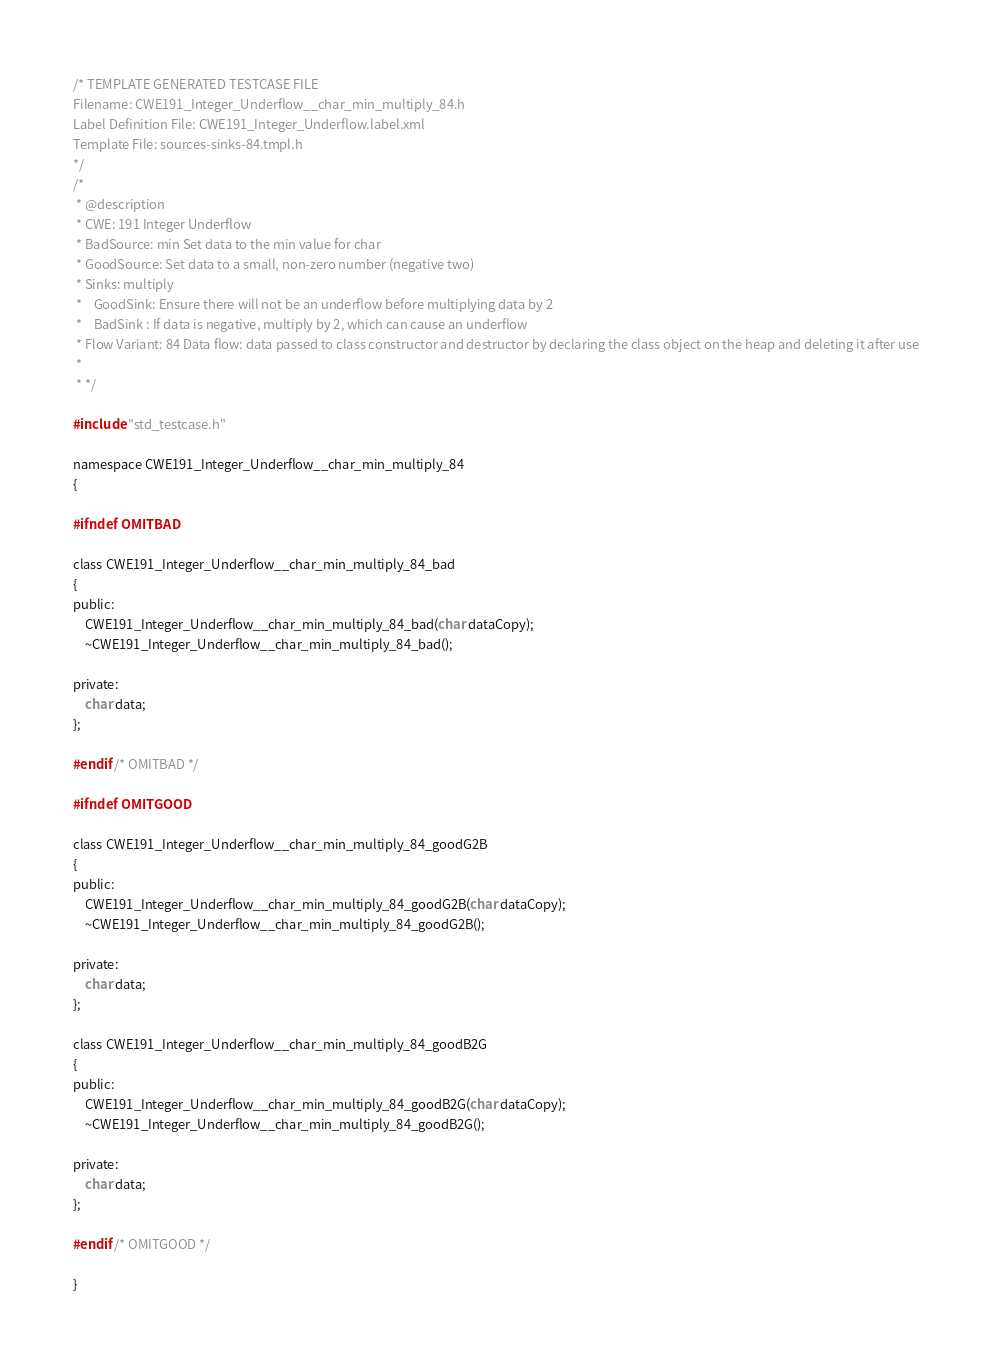<code> <loc_0><loc_0><loc_500><loc_500><_C_>/* TEMPLATE GENERATED TESTCASE FILE
Filename: CWE191_Integer_Underflow__char_min_multiply_84.h
Label Definition File: CWE191_Integer_Underflow.label.xml
Template File: sources-sinks-84.tmpl.h
*/
/*
 * @description
 * CWE: 191 Integer Underflow
 * BadSource: min Set data to the min value for char
 * GoodSource: Set data to a small, non-zero number (negative two)
 * Sinks: multiply
 *    GoodSink: Ensure there will not be an underflow before multiplying data by 2
 *    BadSink : If data is negative, multiply by 2, which can cause an underflow
 * Flow Variant: 84 Data flow: data passed to class constructor and destructor by declaring the class object on the heap and deleting it after use
 *
 * */

#include "std_testcase.h"

namespace CWE191_Integer_Underflow__char_min_multiply_84
{

#ifndef OMITBAD

class CWE191_Integer_Underflow__char_min_multiply_84_bad
{
public:
    CWE191_Integer_Underflow__char_min_multiply_84_bad(char dataCopy);
    ~CWE191_Integer_Underflow__char_min_multiply_84_bad();

private:
    char data;
};

#endif /* OMITBAD */

#ifndef OMITGOOD

class CWE191_Integer_Underflow__char_min_multiply_84_goodG2B
{
public:
    CWE191_Integer_Underflow__char_min_multiply_84_goodG2B(char dataCopy);
    ~CWE191_Integer_Underflow__char_min_multiply_84_goodG2B();

private:
    char data;
};

class CWE191_Integer_Underflow__char_min_multiply_84_goodB2G
{
public:
    CWE191_Integer_Underflow__char_min_multiply_84_goodB2G(char dataCopy);
    ~CWE191_Integer_Underflow__char_min_multiply_84_goodB2G();

private:
    char data;
};

#endif /* OMITGOOD */

}
</code> 